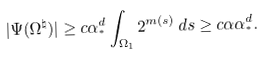Convert formula to latex. <formula><loc_0><loc_0><loc_500><loc_500>| \Psi ( \Omega ^ { \natural } ) | \geq c \alpha _ { ^ { * } } ^ { d } \int _ { \Omega _ { 1 } } 2 ^ { m ( s ) } \, d s \geq c \alpha \alpha _ { ^ { * } } ^ { d } .</formula> 